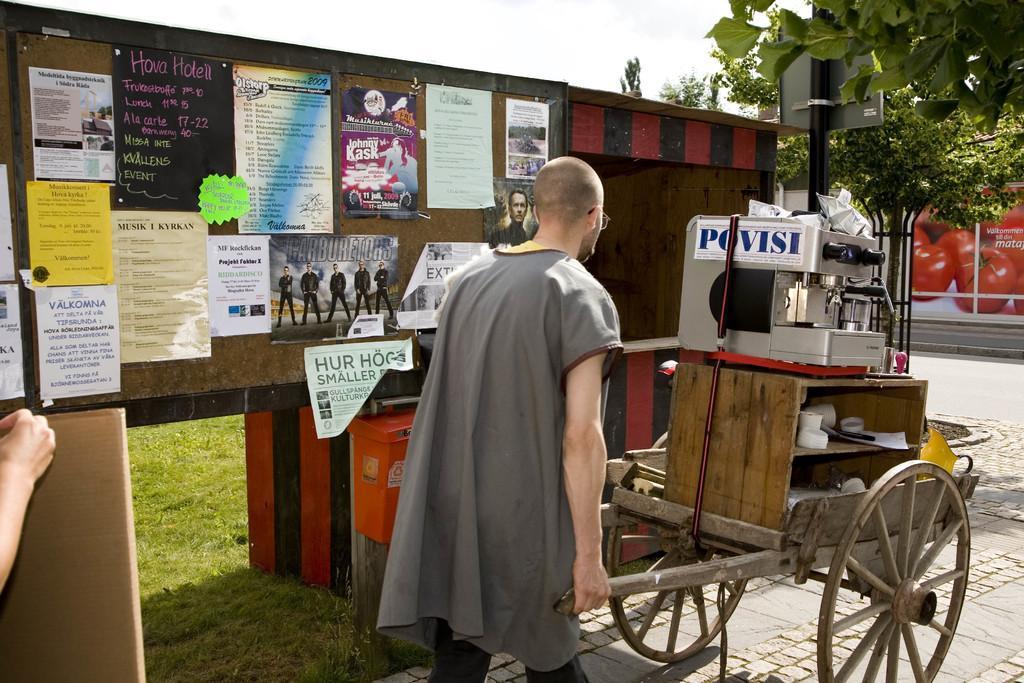Describe this image in one or two sentences. In this image we can see a person standing on the footpath holding a wooden cart containing a machine and a cupboard. On the backside we can see a board with some pictures pasted on it. We can also see some grass, trees, pole with a board, road and the sky. 